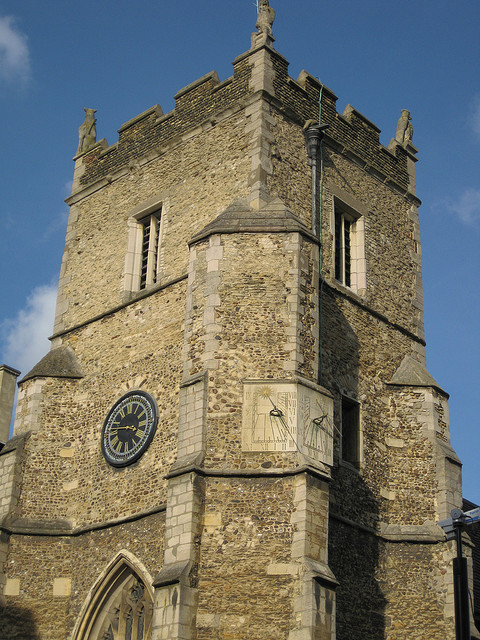<image>Is there a bell in the tower? I am not sure if there is a bell in the tower. The answer could be both 'yes' and 'no'. Is there a bell in the tower? I am not sure if there is a bell in the tower. 